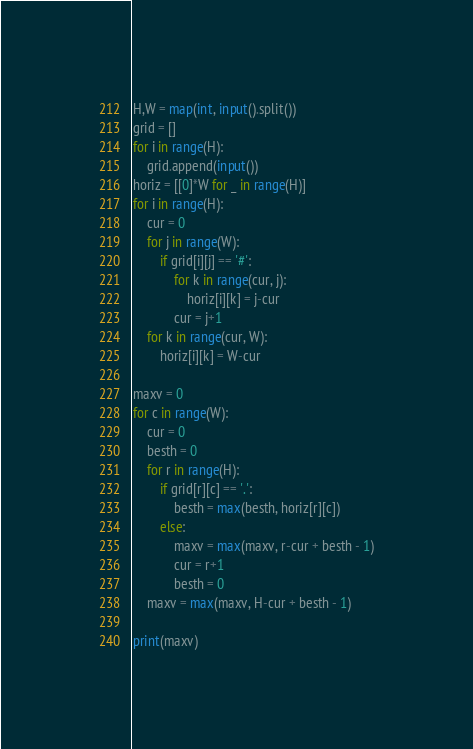Convert code to text. <code><loc_0><loc_0><loc_500><loc_500><_Python_>H,W = map(int, input().split())
grid = []
for i in range(H):
    grid.append(input())
horiz = [[0]*W for _ in range(H)]
for i in range(H):
    cur = 0
    for j in range(W):
        if grid[i][j] == '#':
            for k in range(cur, j):
                horiz[i][k] = j-cur
            cur = j+1
    for k in range(cur, W):
        horiz[i][k] = W-cur

maxv = 0
for c in range(W):
    cur = 0
    besth = 0
    for r in range(H):
        if grid[r][c] == '.':
            besth = max(besth, horiz[r][c])
        else:
            maxv = max(maxv, r-cur + besth - 1)
            cur = r+1
            besth = 0
    maxv = max(maxv, H-cur + besth - 1)

print(maxv)</code> 